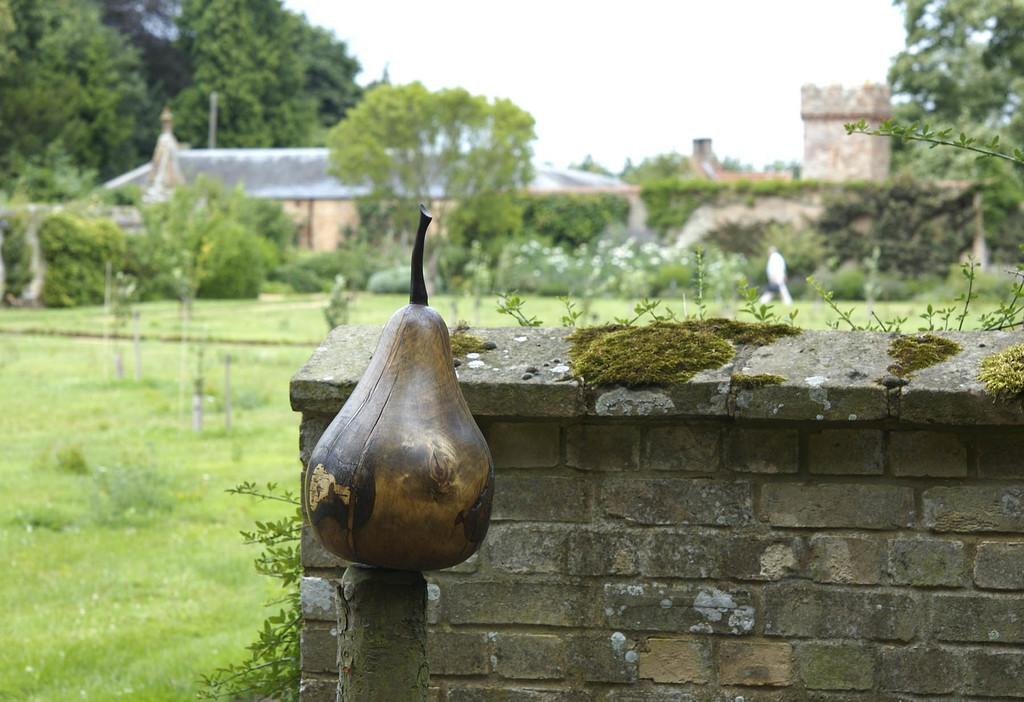What type of fruit is on the bamboo in the image? The fact does not specify the type of fruit on the bamboo. What is located in the foreground of the image? There is a small wall in the foreground of the image. What can be seen in the background of the image? There are plants, grassland, houses, and the sky visible in the background of the image. What direction is the horse facing in the image? There is no horse present in the image. 